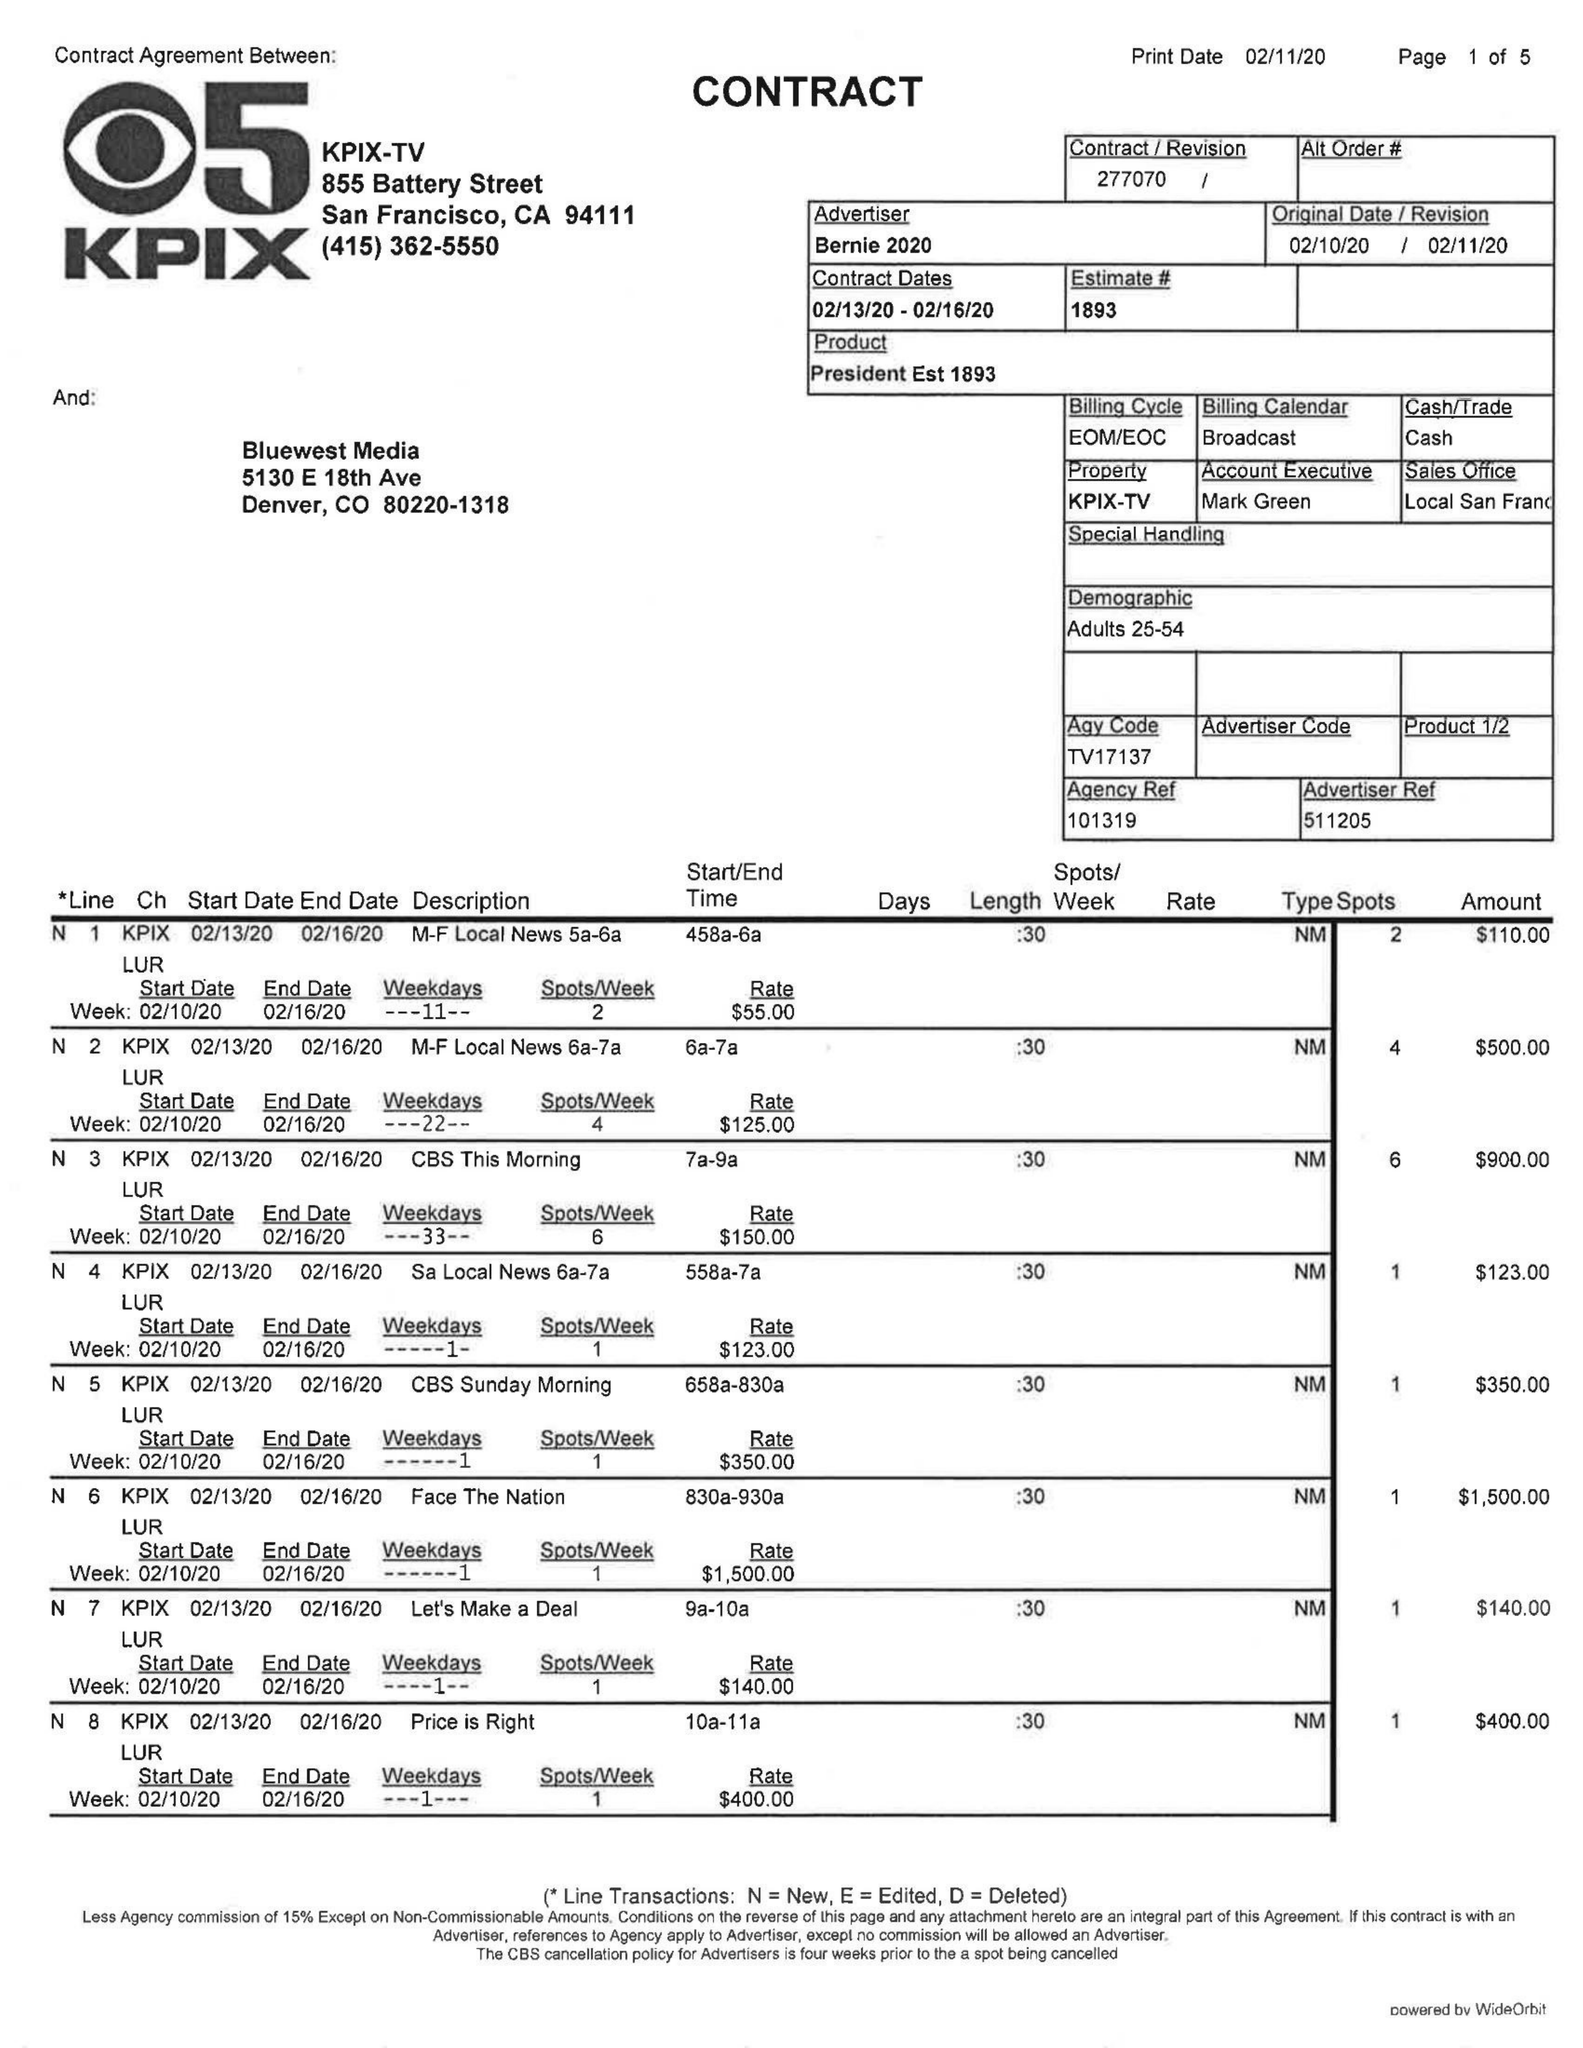What is the value for the advertiser?
Answer the question using a single word or phrase. BERNIE 2020 